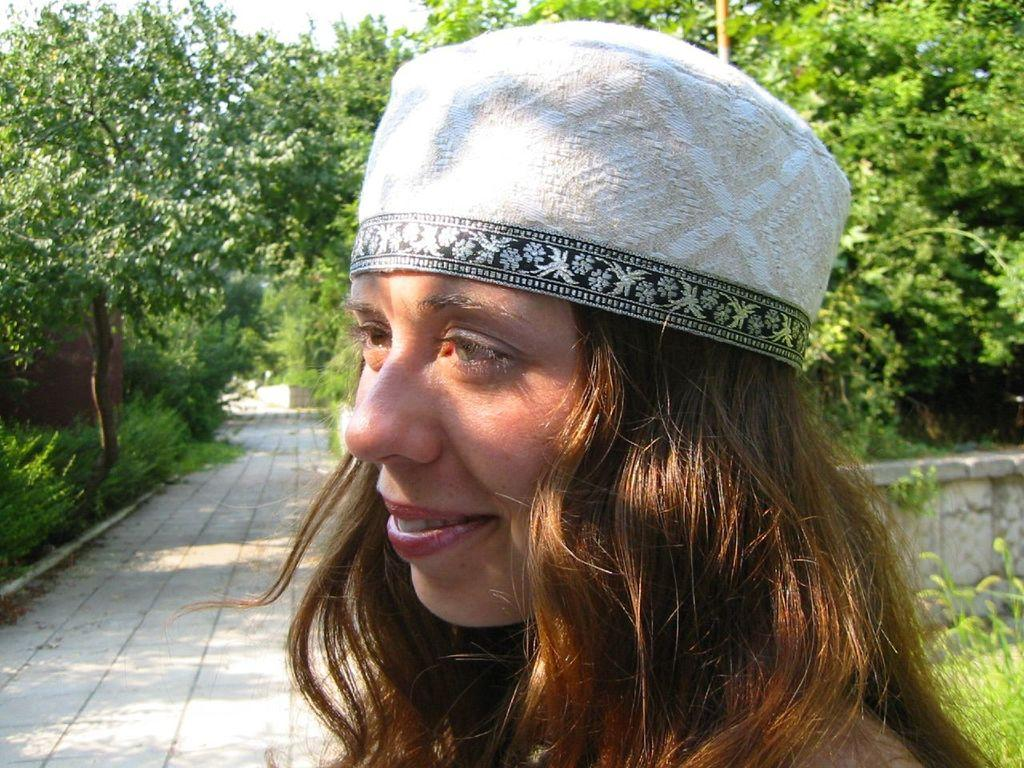Who is present in the image? There is a woman in the image. What is the woman's expression? The woman is smiling. What can be seen in the background of the image? There are trees, bushes, the floor, walls, and the sky visible in the background of the image. What type of soup is being served in the image? There is no soup present in the image. What type of grass can be seen growing in the image? There is no grass visible in the image; only trees, bushes, the floor, walls, and the sky are present in the background. 